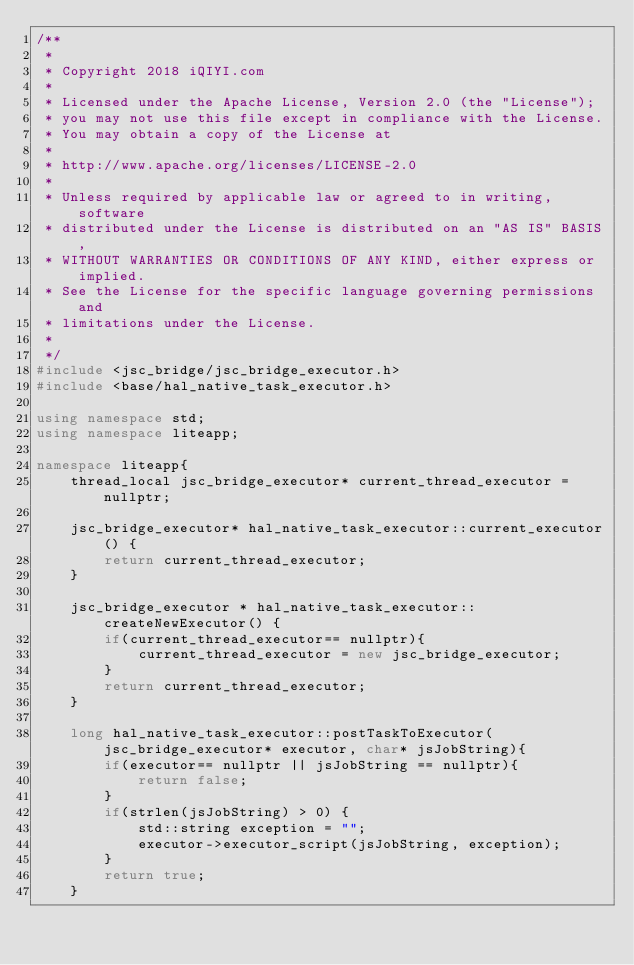Convert code to text. <code><loc_0><loc_0><loc_500><loc_500><_C++_>/**
 *
 * Copyright 2018 iQIYI.com
 *
 * Licensed under the Apache License, Version 2.0 (the "License");
 * you may not use this file except in compliance with the License.
 * You may obtain a copy of the License at
 *
 * http://www.apache.org/licenses/LICENSE-2.0
 *
 * Unless required by applicable law or agreed to in writing, software
 * distributed under the License is distributed on an "AS IS" BASIS,
 * WITHOUT WARRANTIES OR CONDITIONS OF ANY KIND, either express or implied.
 * See the License for the specific language governing permissions and
 * limitations under the License.
 *
 */
#include <jsc_bridge/jsc_bridge_executor.h>
#include <base/hal_native_task_executor.h>

using namespace std;
using namespace liteapp;

namespace liteapp{
    thread_local jsc_bridge_executor* current_thread_executor = nullptr;

    jsc_bridge_executor* hal_native_task_executor::current_executor() {
        return current_thread_executor;
    }

    jsc_bridge_executor * hal_native_task_executor::createNewExecutor() {
        if(current_thread_executor== nullptr){
            current_thread_executor = new jsc_bridge_executor;
        }
        return current_thread_executor;
    }

    long hal_native_task_executor::postTaskToExecutor(jsc_bridge_executor* executor, char* jsJobString){
        if(executor== nullptr || jsJobString == nullptr){
            return false;
        }
        if(strlen(jsJobString) > 0) {
            std::string exception = "";
            executor->executor_script(jsJobString, exception);
        }
        return true;
    }
</code> 